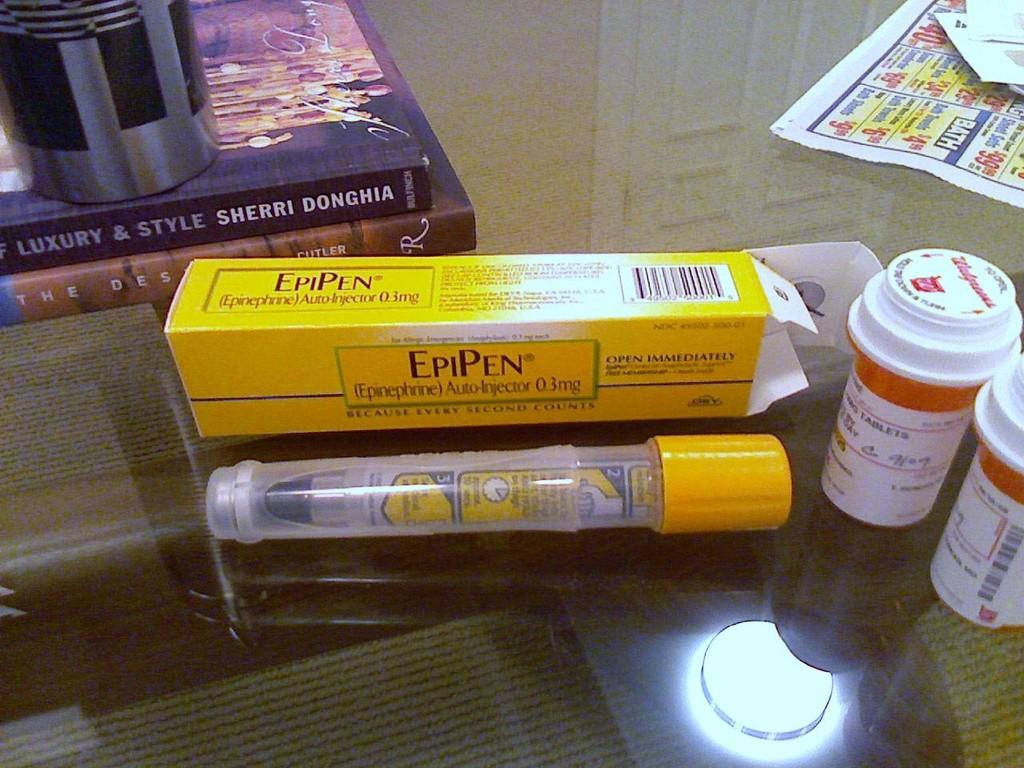What is the name of the pen?
Your answer should be compact. Epipen. Who wrote the top book?
Your response must be concise. Sherri donghia. 